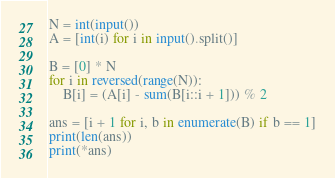<code> <loc_0><loc_0><loc_500><loc_500><_Python_>N = int(input())
A = [int(i) for i in input().split()]

B = [0] * N
for i in reversed(range(N)):
    B[i] = (A[i] - sum(B[i::i + 1])) % 2

ans = [i + 1 for i, b in enumerate(B) if b == 1]
print(len(ans))
print(*ans)</code> 